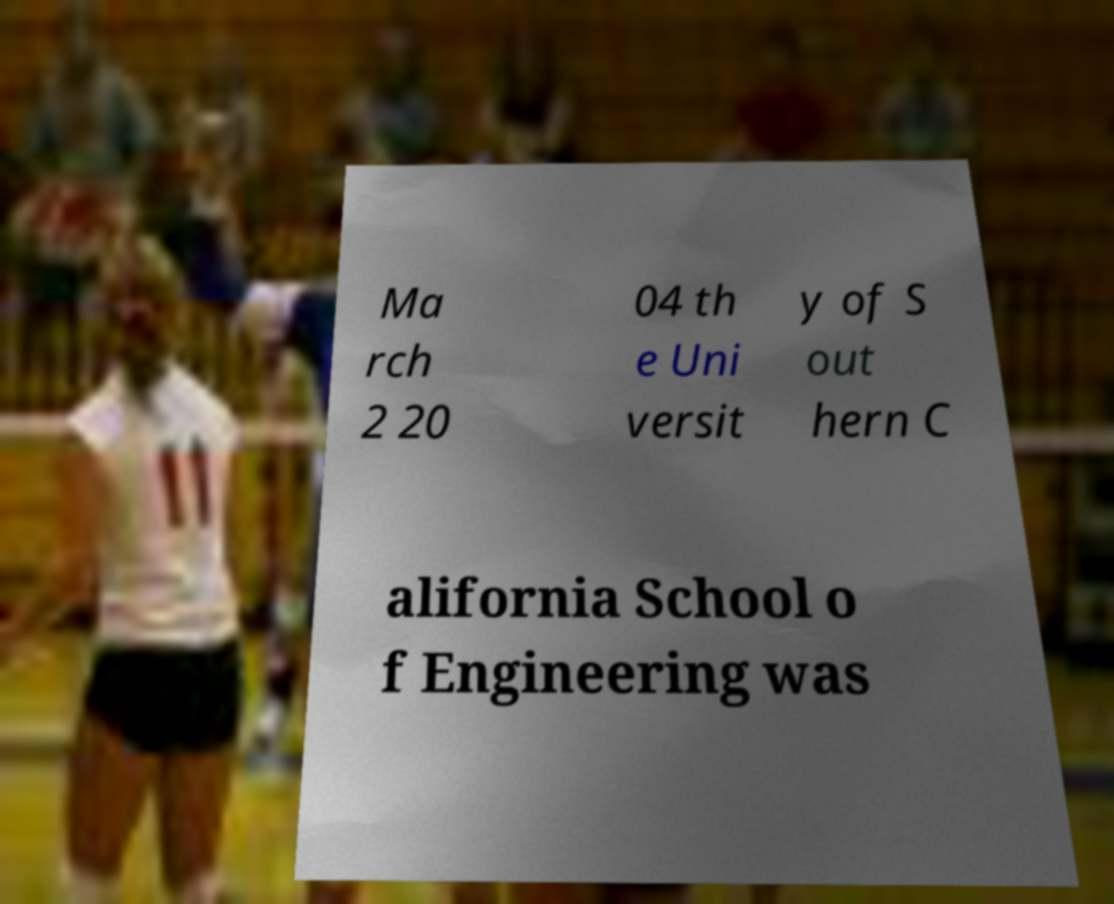Could you assist in decoding the text presented in this image and type it out clearly? Ma rch 2 20 04 th e Uni versit y of S out hern C alifornia School o f Engineering was 